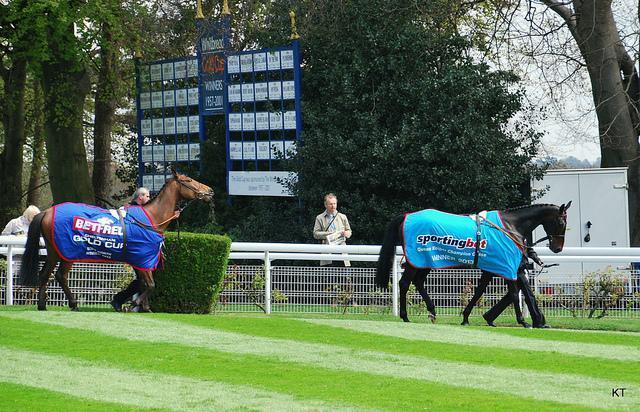How many horses are there?
Give a very brief answer. 2. How many of the train cars are yellow and red?
Give a very brief answer. 0. 